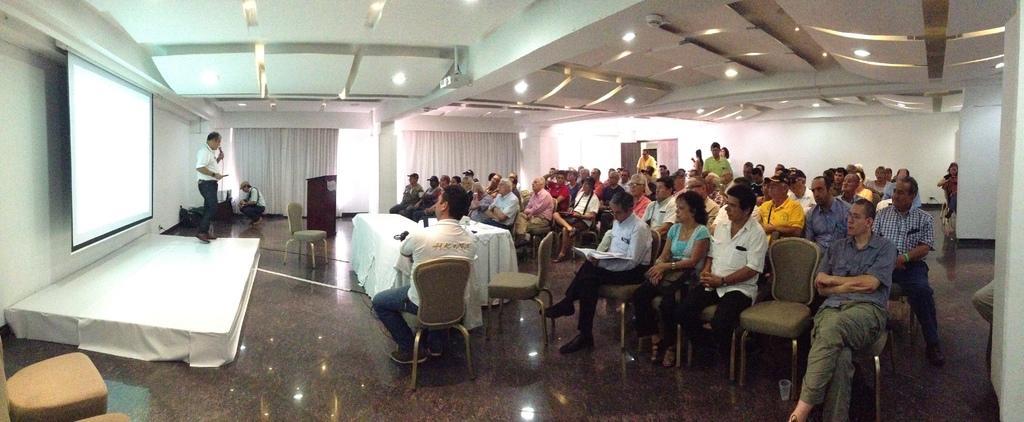Can you describe this image briefly? In this image, I can see groups of people sitting in the chairs and few people standing. This looks like a podium. I can see the ceiling lights, which are attached to the ceiling. These are the curtains hanging. Here is a person sitting in squat position. This is a stage. This is a screen with the display. 